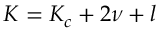Convert formula to latex. <formula><loc_0><loc_0><loc_500><loc_500>K = K _ { c } + 2 \nu + l</formula> 